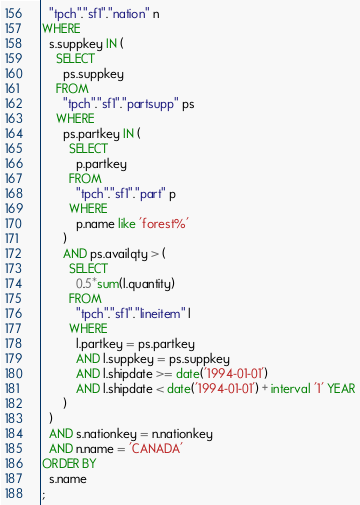Convert code to text. <code><loc_0><loc_0><loc_500><loc_500><_SQL_>  "tpch"."sf1"."nation" n
WHERE
  s.suppkey IN (
    SELECT
      ps.suppkey
    FROM
      "tpch"."sf1"."partsupp" ps
    WHERE
      ps.partkey IN (
        SELECT
          p.partkey
        FROM
          "tpch"."sf1"."part" p
        WHERE
          p.name like 'forest%'
      )
      AND ps.availqty > (
        SELECT
          0.5*sum(l.quantity)
        FROM
          "tpch"."sf1"."lineitem" l
        WHERE
          l.partkey = ps.partkey
          AND l.suppkey = ps.suppkey
          AND l.shipdate >= date('1994-01-01')
          AND l.shipdate < date('1994-01-01') + interval '1' YEAR
      )
  )
  AND s.nationkey = n.nationkey
  AND n.name = 'CANADA'
ORDER BY
  s.name
;</code> 